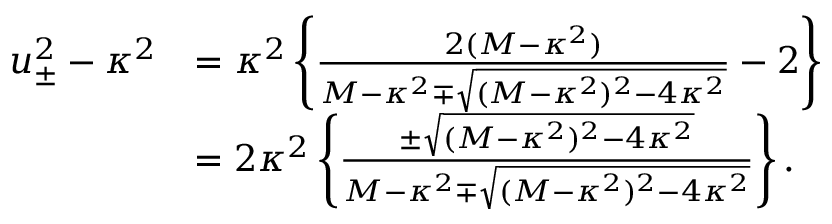<formula> <loc_0><loc_0><loc_500><loc_500>\begin{array} { r l } { u _ { \pm } ^ { 2 } - \kappa ^ { 2 } } & { = \kappa ^ { 2 } \left \{ \frac { 2 ( M - \kappa ^ { 2 } ) } { M - \kappa ^ { 2 } \mp \sqrt { ( M - \kappa ^ { 2 } ) ^ { 2 } - 4 \kappa ^ { 2 } } } - 2 \right \} } \\ & { = 2 \kappa ^ { 2 } \left \{ \frac { \pm \sqrt { ( M - \kappa ^ { 2 } ) ^ { 2 } - 4 \kappa ^ { 2 } } } { M - \kappa ^ { 2 } \mp \sqrt { ( M - \kappa ^ { 2 } ) ^ { 2 } - 4 \kappa ^ { 2 } } } \right \} . } \end{array}</formula> 